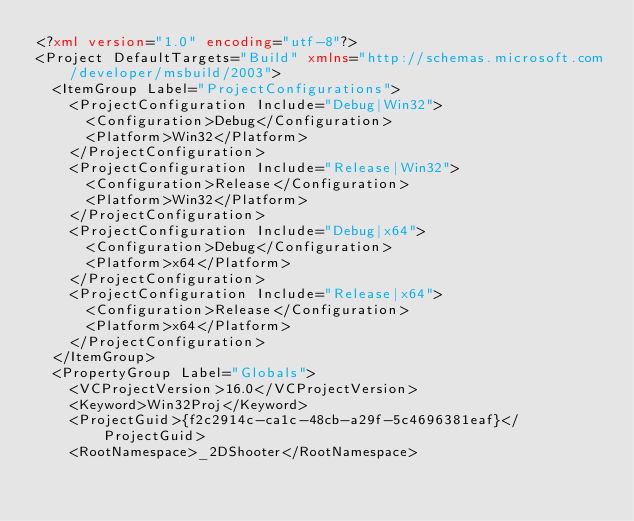<code> <loc_0><loc_0><loc_500><loc_500><_XML_><?xml version="1.0" encoding="utf-8"?>
<Project DefaultTargets="Build" xmlns="http://schemas.microsoft.com/developer/msbuild/2003">
  <ItemGroup Label="ProjectConfigurations">
    <ProjectConfiguration Include="Debug|Win32">
      <Configuration>Debug</Configuration>
      <Platform>Win32</Platform>
    </ProjectConfiguration>
    <ProjectConfiguration Include="Release|Win32">
      <Configuration>Release</Configuration>
      <Platform>Win32</Platform>
    </ProjectConfiguration>
    <ProjectConfiguration Include="Debug|x64">
      <Configuration>Debug</Configuration>
      <Platform>x64</Platform>
    </ProjectConfiguration>
    <ProjectConfiguration Include="Release|x64">
      <Configuration>Release</Configuration>
      <Platform>x64</Platform>
    </ProjectConfiguration>
  </ItemGroup>
  <PropertyGroup Label="Globals">
    <VCProjectVersion>16.0</VCProjectVersion>
    <Keyword>Win32Proj</Keyword>
    <ProjectGuid>{f2c2914c-ca1c-48cb-a29f-5c4696381eaf}</ProjectGuid>
    <RootNamespace>_2DShooter</RootNamespace></code> 